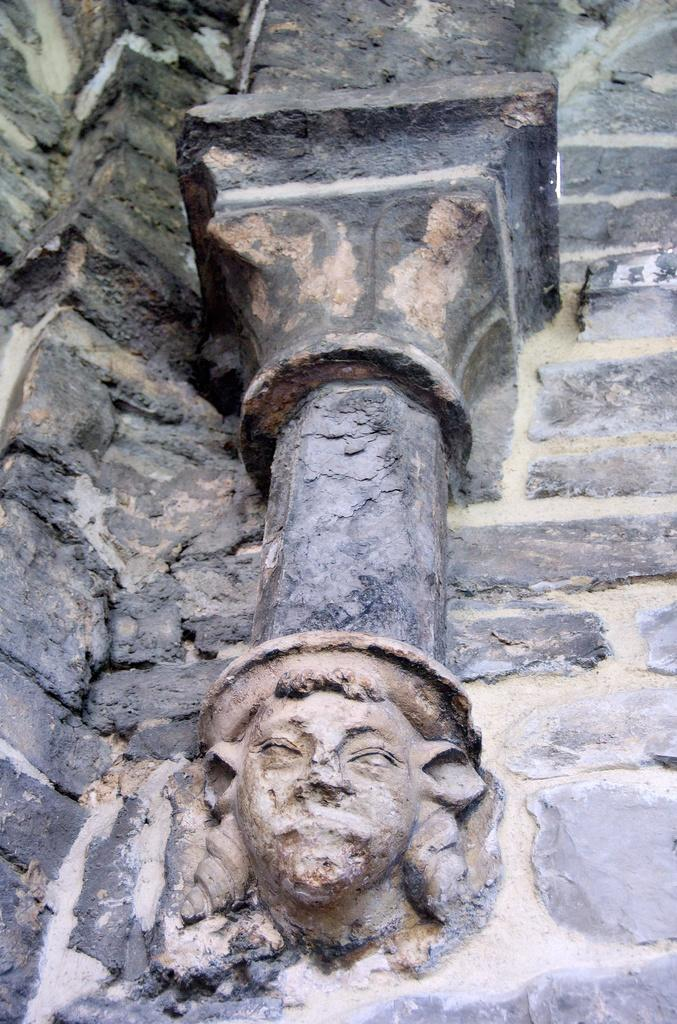What type of structure is present in the image? There is a stone wall in the image. What can be seen on the stone wall? There is a sculpture on the stone wall. What type of curtain is hanging from the sculpture in the image? There is no curtain present in the image; it features a stone wall with a sculpture on it. 